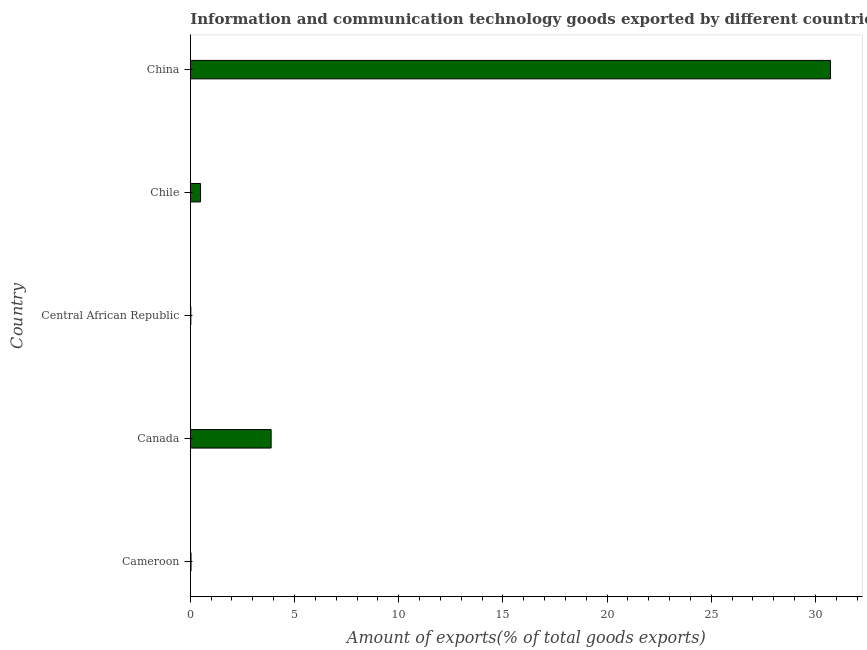Does the graph contain any zero values?
Your answer should be very brief. No. What is the title of the graph?
Keep it short and to the point. Information and communication technology goods exported by different countries. What is the label or title of the X-axis?
Ensure brevity in your answer.  Amount of exports(% of total goods exports). What is the amount of ict goods exports in Cameroon?
Offer a terse response. 0.04. Across all countries, what is the maximum amount of ict goods exports?
Your answer should be compact. 30.72. Across all countries, what is the minimum amount of ict goods exports?
Your answer should be very brief. 0.03. In which country was the amount of ict goods exports maximum?
Offer a terse response. China. In which country was the amount of ict goods exports minimum?
Offer a very short reply. Central African Republic. What is the sum of the amount of ict goods exports?
Your answer should be very brief. 35.15. What is the difference between the amount of ict goods exports in Canada and China?
Make the answer very short. -26.84. What is the average amount of ict goods exports per country?
Provide a succinct answer. 7.03. What is the median amount of ict goods exports?
Provide a succinct answer. 0.49. What is the ratio of the amount of ict goods exports in Cameroon to that in Canada?
Give a very brief answer. 0.01. Is the amount of ict goods exports in Cameroon less than that in Canada?
Your answer should be very brief. Yes. What is the difference between the highest and the second highest amount of ict goods exports?
Offer a terse response. 26.84. Is the sum of the amount of ict goods exports in Cameroon and Canada greater than the maximum amount of ict goods exports across all countries?
Make the answer very short. No. What is the difference between the highest and the lowest amount of ict goods exports?
Provide a succinct answer. 30.7. What is the difference between two consecutive major ticks on the X-axis?
Keep it short and to the point. 5. Are the values on the major ticks of X-axis written in scientific E-notation?
Make the answer very short. No. What is the Amount of exports(% of total goods exports) in Cameroon?
Keep it short and to the point. 0.04. What is the Amount of exports(% of total goods exports) in Canada?
Give a very brief answer. 3.88. What is the Amount of exports(% of total goods exports) of Central African Republic?
Ensure brevity in your answer.  0.03. What is the Amount of exports(% of total goods exports) in Chile?
Give a very brief answer. 0.49. What is the Amount of exports(% of total goods exports) in China?
Make the answer very short. 30.72. What is the difference between the Amount of exports(% of total goods exports) in Cameroon and Canada?
Keep it short and to the point. -3.85. What is the difference between the Amount of exports(% of total goods exports) in Cameroon and Central African Republic?
Make the answer very short. 0.01. What is the difference between the Amount of exports(% of total goods exports) in Cameroon and Chile?
Offer a terse response. -0.46. What is the difference between the Amount of exports(% of total goods exports) in Cameroon and China?
Make the answer very short. -30.69. What is the difference between the Amount of exports(% of total goods exports) in Canada and Central African Republic?
Your answer should be very brief. 3.85. What is the difference between the Amount of exports(% of total goods exports) in Canada and Chile?
Offer a very short reply. 3.39. What is the difference between the Amount of exports(% of total goods exports) in Canada and China?
Your response must be concise. -26.84. What is the difference between the Amount of exports(% of total goods exports) in Central African Republic and Chile?
Make the answer very short. -0.47. What is the difference between the Amount of exports(% of total goods exports) in Central African Republic and China?
Provide a short and direct response. -30.7. What is the difference between the Amount of exports(% of total goods exports) in Chile and China?
Offer a very short reply. -30.23. What is the ratio of the Amount of exports(% of total goods exports) in Cameroon to that in Canada?
Offer a terse response. 0.01. What is the ratio of the Amount of exports(% of total goods exports) in Cameroon to that in Central African Republic?
Give a very brief answer. 1.36. What is the ratio of the Amount of exports(% of total goods exports) in Cameroon to that in Chile?
Offer a very short reply. 0.07. What is the ratio of the Amount of exports(% of total goods exports) in Canada to that in Central African Republic?
Ensure brevity in your answer.  150.72. What is the ratio of the Amount of exports(% of total goods exports) in Canada to that in Chile?
Provide a succinct answer. 7.9. What is the ratio of the Amount of exports(% of total goods exports) in Canada to that in China?
Ensure brevity in your answer.  0.13. What is the ratio of the Amount of exports(% of total goods exports) in Central African Republic to that in Chile?
Give a very brief answer. 0.05. What is the ratio of the Amount of exports(% of total goods exports) in Central African Republic to that in China?
Your response must be concise. 0. What is the ratio of the Amount of exports(% of total goods exports) in Chile to that in China?
Keep it short and to the point. 0.02. 